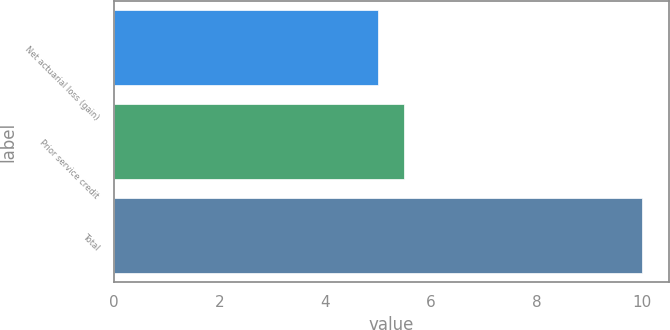<chart> <loc_0><loc_0><loc_500><loc_500><bar_chart><fcel>Net actuarial loss (gain)<fcel>Prior service credit<fcel>Total<nl><fcel>5<fcel>5.5<fcel>10<nl></chart> 